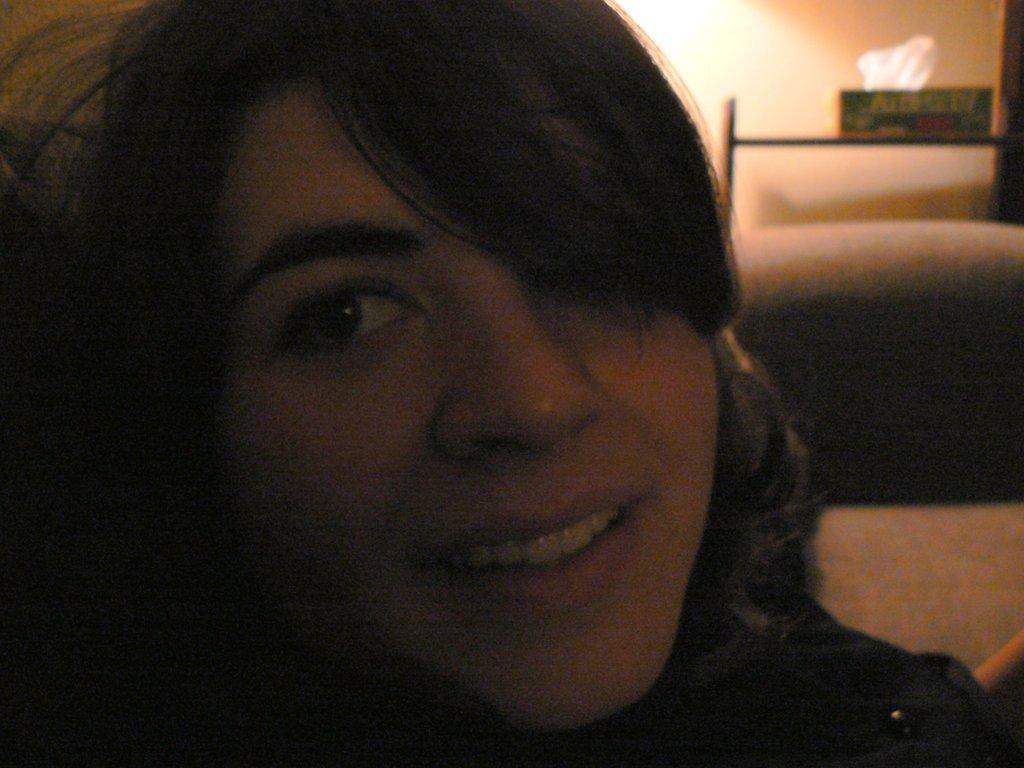What is the main subject of the image? There is a woman's face in the center of the image. How many icicles are hanging from the woman's face in the image? There are no icicles present in the image; it features a woman's face. What type of lamp is illuminating the woman's face in the image? There is no lamp present in the image; it only features the woman's face. 